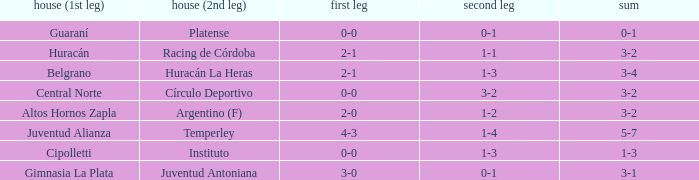Who played at home for the 2nd leg with a score of 1-2? Argentino (F). Can you parse all the data within this table? {'header': ['house (1st leg)', 'house (2nd leg)', 'first leg', 'second leg', 'sum'], 'rows': [['Guaraní', 'Platense', '0-0', '0-1', '0-1'], ['Huracán', 'Racing de Córdoba', '2-1', '1-1', '3-2'], ['Belgrano', 'Huracán La Heras', '2-1', '1-3', '3-4'], ['Central Norte', 'Círculo Deportivo', '0-0', '3-2', '3-2'], ['Altos Hornos Zapla', 'Argentino (F)', '2-0', '1-2', '3-2'], ['Juventud Alianza', 'Temperley', '4-3', '1-4', '5-7'], ['Cipolletti', 'Instituto', '0-0', '1-3', '1-3'], ['Gimnasia La Plata', 'Juventud Antoniana', '3-0', '0-1', '3-1']]} 